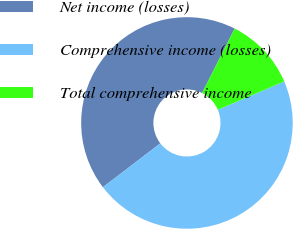<chart> <loc_0><loc_0><loc_500><loc_500><pie_chart><fcel>Net income (losses)<fcel>Comprehensive income (losses)<fcel>Total comprehensive income<nl><fcel>42.85%<fcel>46.02%<fcel>11.13%<nl></chart> 